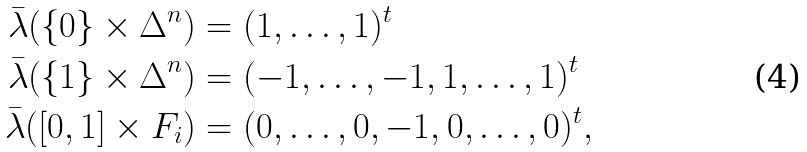Convert formula to latex. <formula><loc_0><loc_0><loc_500><loc_500>\bar { \lambda } ( \{ 0 \} \times \Delta ^ { n } ) & = ( 1 , \dots , 1 ) ^ { t } \\ \bar { \lambda } ( \{ 1 \} \times \Delta ^ { n } ) & = ( - 1 , \dots , - 1 , 1 , \dots , 1 ) ^ { t } \\ \bar { \lambda } ( [ 0 , 1 ] \times F _ { i } ) & = ( 0 , \dots , 0 , - 1 , 0 , \dots , 0 ) ^ { t } ,</formula> 